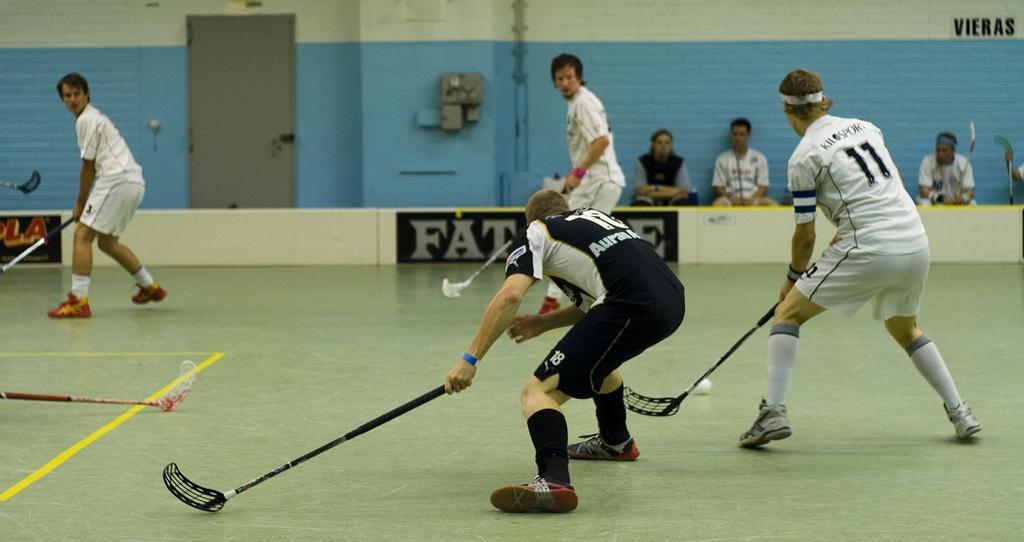In one or two sentences, can you explain what this image depicts? In the picture there are few people playing floor ball game and behind them there are other people sitting and watching the game. 